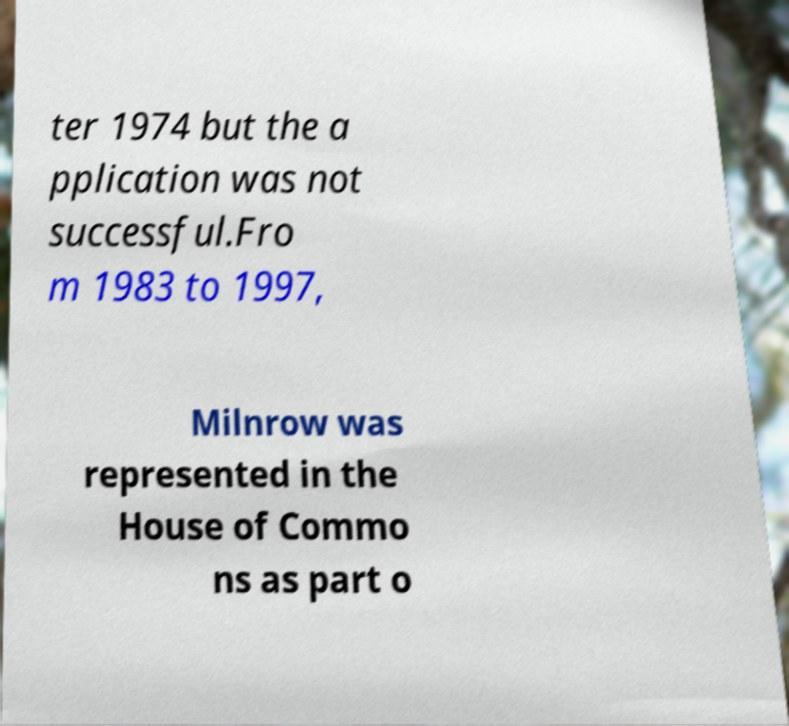What messages or text are displayed in this image? I need them in a readable, typed format. ter 1974 but the a pplication was not successful.Fro m 1983 to 1997, Milnrow was represented in the House of Commo ns as part o 